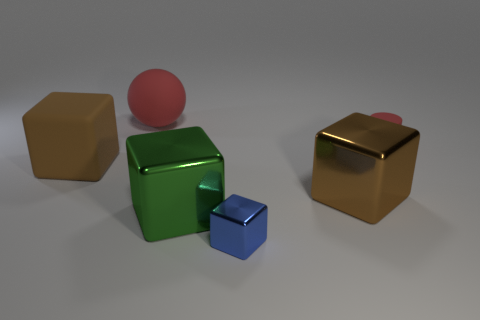The thing that is the same color as the cylinder is what size?
Offer a very short reply. Large. Is the material of the tiny red thing the same as the large red ball?
Provide a succinct answer. Yes. There is a matte object that is the same size as the red sphere; what is its color?
Offer a very short reply. Brown. What number of other small yellow objects have the same shape as the small metal thing?
Offer a very short reply. 0. Do the brown matte cube and the red matte thing that is left of the red rubber cylinder have the same size?
Provide a succinct answer. Yes. There is a brown object on the right side of the metallic object on the left side of the tiny shiny thing; what is its shape?
Your answer should be compact. Cube. Is the number of large matte things that are on the right side of the small block less than the number of big rubber objects?
Your answer should be very brief. Yes. What is the shape of the matte thing that is the same color as the rubber cylinder?
Offer a terse response. Sphere. How many green cubes are the same size as the blue thing?
Offer a very short reply. 0. There is a matte thing that is on the left side of the big red matte sphere; what is its shape?
Offer a terse response. Cube. 